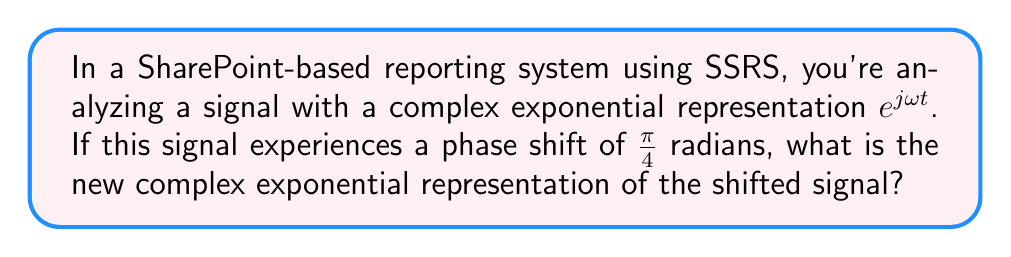Give your solution to this math problem. To solve this problem, we'll follow these steps:

1) The original signal is represented by $e^{j\omega t}$.

2) A phase shift of $\phi$ radians is represented by multiplying the original signal by $e^{j\phi}$.

3) In this case, the phase shift $\phi = \frac{\pi}{4}$ radians.

4) Therefore, we multiply the original signal by $e^{j\frac{\pi}{4}}$:

   $e^{j\omega t} \cdot e^{j\frac{\pi}{4}}$

5) Using the properties of complex exponentials, we can combine the exponents:

   $e^{j(\omega t + \frac{\pi}{4})}$

This is the new complex exponential representation of the shifted signal.
Answer: $e^{j(\omega t + \frac{\pi}{4})}$ 